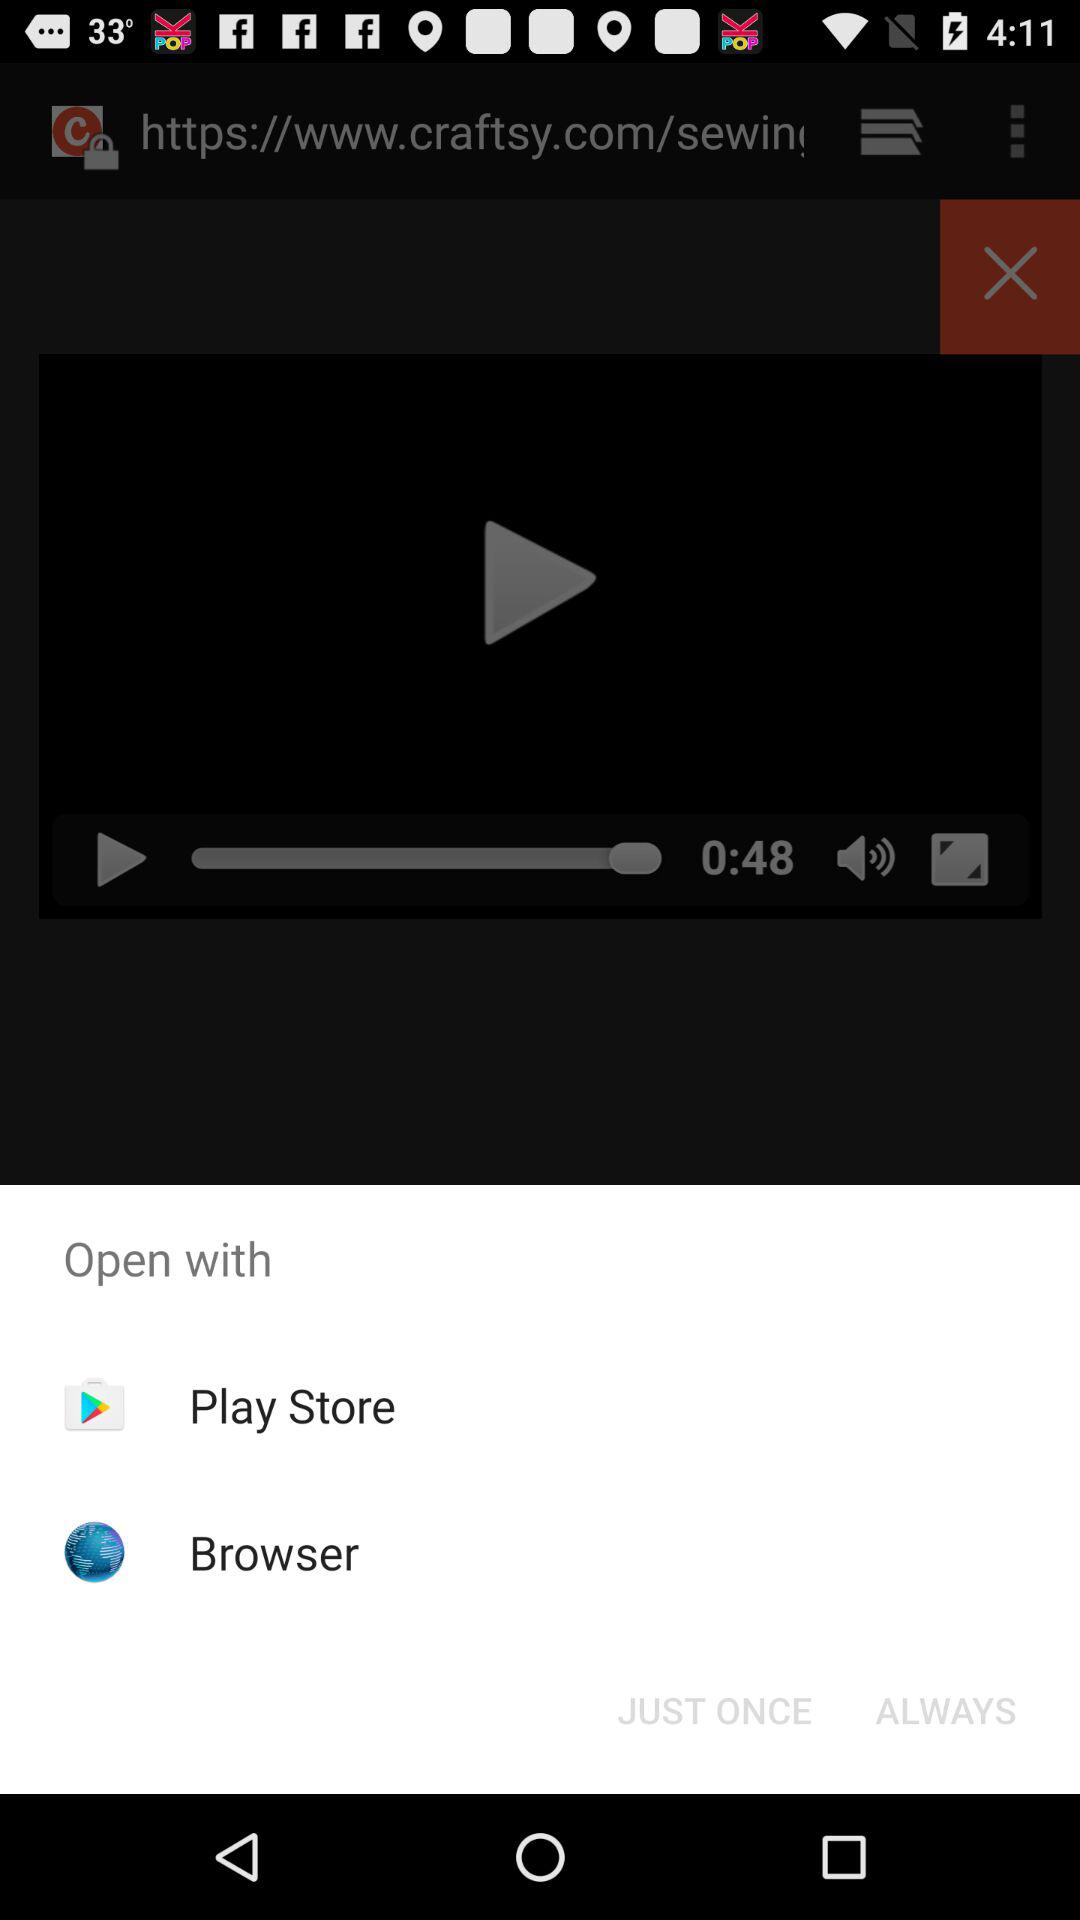Which applications can be used to open? The applications are "Play Store" and "Browser". 